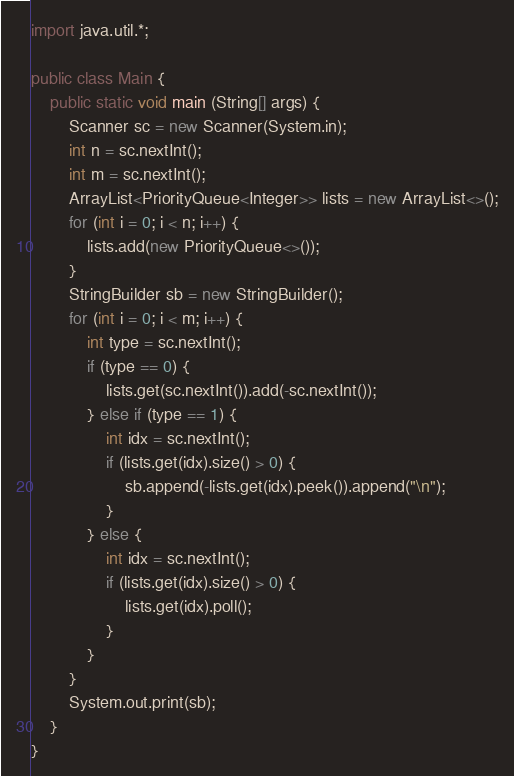<code> <loc_0><loc_0><loc_500><loc_500><_Java_>import java.util.*;

public class Main {
	public static void main (String[] args) {
		Scanner sc = new Scanner(System.in);
		int n = sc.nextInt();
		int m = sc.nextInt();
		ArrayList<PriorityQueue<Integer>> lists = new ArrayList<>();
		for (int i = 0; i < n; i++) {
		    lists.add(new PriorityQueue<>());
		}
		StringBuilder sb = new StringBuilder();
		for (int i = 0; i < m; i++) {
		    int type = sc.nextInt();
		    if (type == 0) {
		        lists.get(sc.nextInt()).add(-sc.nextInt());
		    } else if (type == 1) {
		        int idx = sc.nextInt();
		        if (lists.get(idx).size() > 0) {
		            sb.append(-lists.get(idx).peek()).append("\n");
		        }
		    } else {
		        int idx = sc.nextInt();
		        if (lists.get(idx).size() > 0) {
		            lists.get(idx).poll();
		        }
		    }
		}
		System.out.print(sb);
	}
}

</code> 